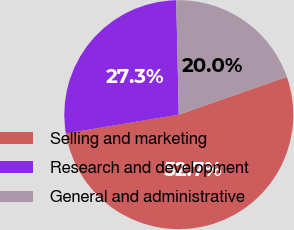Convert chart. <chart><loc_0><loc_0><loc_500><loc_500><pie_chart><fcel>Selling and marketing<fcel>Research and development<fcel>General and administrative<nl><fcel>52.73%<fcel>27.27%<fcel>20.0%<nl></chart> 